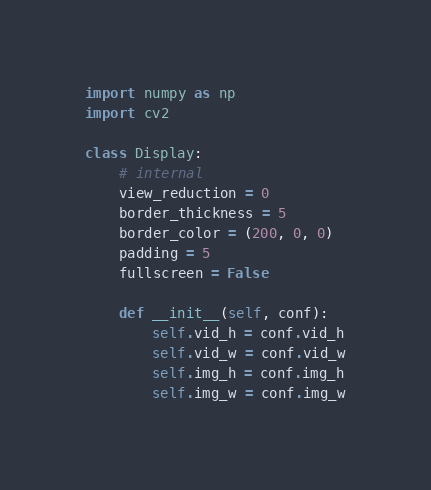Convert code to text. <code><loc_0><loc_0><loc_500><loc_500><_Python_>import numpy as np
import cv2

class Display:
    # internal
    view_reduction = 0
    border_thickness = 5
    border_color = (200, 0, 0)
    padding = 5
    fullscreen = False

    def __init__(self, conf):
        self.vid_h = conf.vid_h
        self.vid_w = conf.vid_w
        self.img_h = conf.img_h
        self.img_w = conf.img_w</code> 